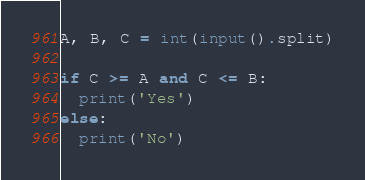<code> <loc_0><loc_0><loc_500><loc_500><_Python_>A, B, C = int(input().split)

if C >= A and C <= B:
  print('Yes')
else:
  print('No')</code> 